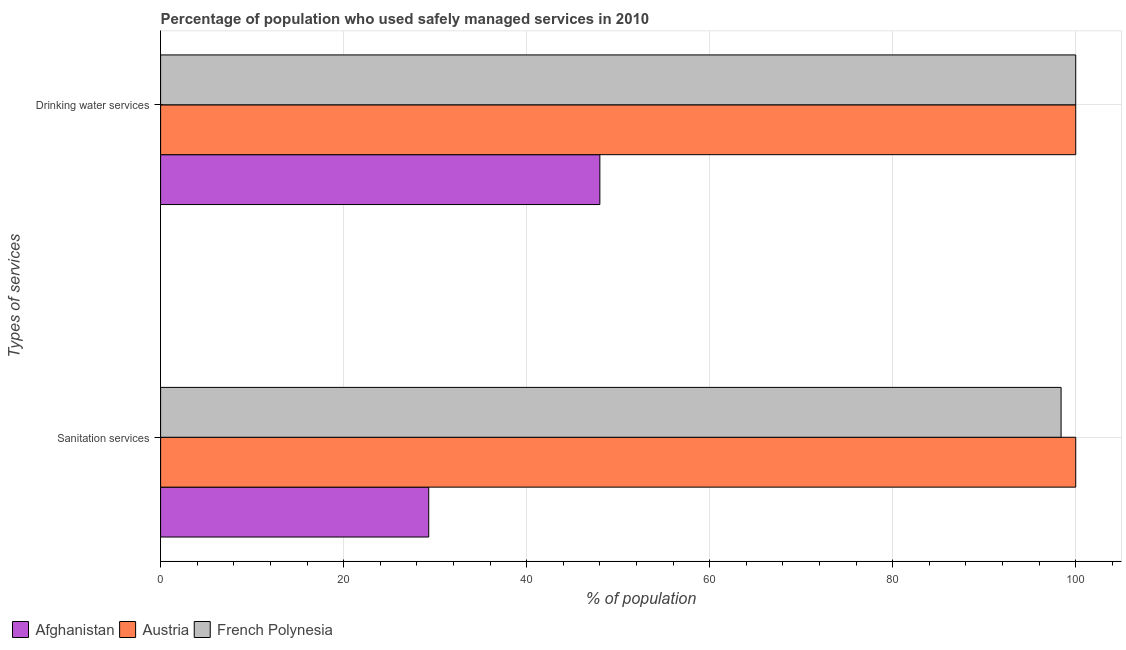How many different coloured bars are there?
Your response must be concise. 3. How many groups of bars are there?
Offer a terse response. 2. Are the number of bars on each tick of the Y-axis equal?
Make the answer very short. Yes. How many bars are there on the 2nd tick from the bottom?
Make the answer very short. 3. What is the label of the 1st group of bars from the top?
Provide a short and direct response. Drinking water services. What is the percentage of population who used sanitation services in Austria?
Give a very brief answer. 100. Across all countries, what is the minimum percentage of population who used drinking water services?
Give a very brief answer. 48. In which country was the percentage of population who used sanitation services maximum?
Ensure brevity in your answer.  Austria. In which country was the percentage of population who used sanitation services minimum?
Make the answer very short. Afghanistan. What is the total percentage of population who used drinking water services in the graph?
Your answer should be compact. 248. What is the difference between the percentage of population who used sanitation services in Afghanistan and that in Austria?
Make the answer very short. -70.7. What is the difference between the percentage of population who used drinking water services in Austria and the percentage of population who used sanitation services in Afghanistan?
Your answer should be very brief. 70.7. What is the average percentage of population who used sanitation services per country?
Keep it short and to the point. 75.9. In how many countries, is the percentage of population who used sanitation services greater than 8 %?
Offer a terse response. 3. What is the ratio of the percentage of population who used sanitation services in Austria to that in Afghanistan?
Ensure brevity in your answer.  3.41. Is the percentage of population who used drinking water services in Austria less than that in French Polynesia?
Your answer should be very brief. No. In how many countries, is the percentage of population who used drinking water services greater than the average percentage of population who used drinking water services taken over all countries?
Your response must be concise. 2. What does the 3rd bar from the top in Drinking water services represents?
Offer a very short reply. Afghanistan. What does the 1st bar from the bottom in Sanitation services represents?
Provide a succinct answer. Afghanistan. How many countries are there in the graph?
Your answer should be very brief. 3. Does the graph contain any zero values?
Provide a short and direct response. No. Where does the legend appear in the graph?
Your answer should be very brief. Bottom left. How many legend labels are there?
Ensure brevity in your answer.  3. How are the legend labels stacked?
Provide a short and direct response. Horizontal. What is the title of the graph?
Offer a terse response. Percentage of population who used safely managed services in 2010. What is the label or title of the X-axis?
Make the answer very short. % of population. What is the label or title of the Y-axis?
Offer a very short reply. Types of services. What is the % of population in Afghanistan in Sanitation services?
Your answer should be very brief. 29.3. What is the % of population in French Polynesia in Sanitation services?
Provide a succinct answer. 98.4. What is the % of population in Austria in Drinking water services?
Keep it short and to the point. 100. Across all Types of services, what is the maximum % of population of Austria?
Offer a very short reply. 100. Across all Types of services, what is the minimum % of population of Afghanistan?
Your answer should be compact. 29.3. Across all Types of services, what is the minimum % of population of Austria?
Keep it short and to the point. 100. Across all Types of services, what is the minimum % of population in French Polynesia?
Your answer should be very brief. 98.4. What is the total % of population of Afghanistan in the graph?
Provide a short and direct response. 77.3. What is the total % of population of French Polynesia in the graph?
Provide a short and direct response. 198.4. What is the difference between the % of population of Afghanistan in Sanitation services and that in Drinking water services?
Your answer should be very brief. -18.7. What is the difference between the % of population in French Polynesia in Sanitation services and that in Drinking water services?
Provide a short and direct response. -1.6. What is the difference between the % of population in Afghanistan in Sanitation services and the % of population in Austria in Drinking water services?
Your response must be concise. -70.7. What is the difference between the % of population of Afghanistan in Sanitation services and the % of population of French Polynesia in Drinking water services?
Keep it short and to the point. -70.7. What is the difference between the % of population of Austria in Sanitation services and the % of population of French Polynesia in Drinking water services?
Give a very brief answer. 0. What is the average % of population of Afghanistan per Types of services?
Offer a very short reply. 38.65. What is the average % of population of Austria per Types of services?
Your answer should be compact. 100. What is the average % of population of French Polynesia per Types of services?
Keep it short and to the point. 99.2. What is the difference between the % of population of Afghanistan and % of population of Austria in Sanitation services?
Offer a terse response. -70.7. What is the difference between the % of population in Afghanistan and % of population in French Polynesia in Sanitation services?
Provide a short and direct response. -69.1. What is the difference between the % of population in Afghanistan and % of population in Austria in Drinking water services?
Provide a succinct answer. -52. What is the difference between the % of population of Afghanistan and % of population of French Polynesia in Drinking water services?
Give a very brief answer. -52. What is the ratio of the % of population in Afghanistan in Sanitation services to that in Drinking water services?
Your response must be concise. 0.61. What is the ratio of the % of population of Austria in Sanitation services to that in Drinking water services?
Your answer should be very brief. 1. What is the difference between the highest and the second highest % of population of Austria?
Offer a terse response. 0. What is the difference between the highest and the second highest % of population in French Polynesia?
Provide a short and direct response. 1.6. What is the difference between the highest and the lowest % of population of Austria?
Make the answer very short. 0. What is the difference between the highest and the lowest % of population in French Polynesia?
Offer a very short reply. 1.6. 